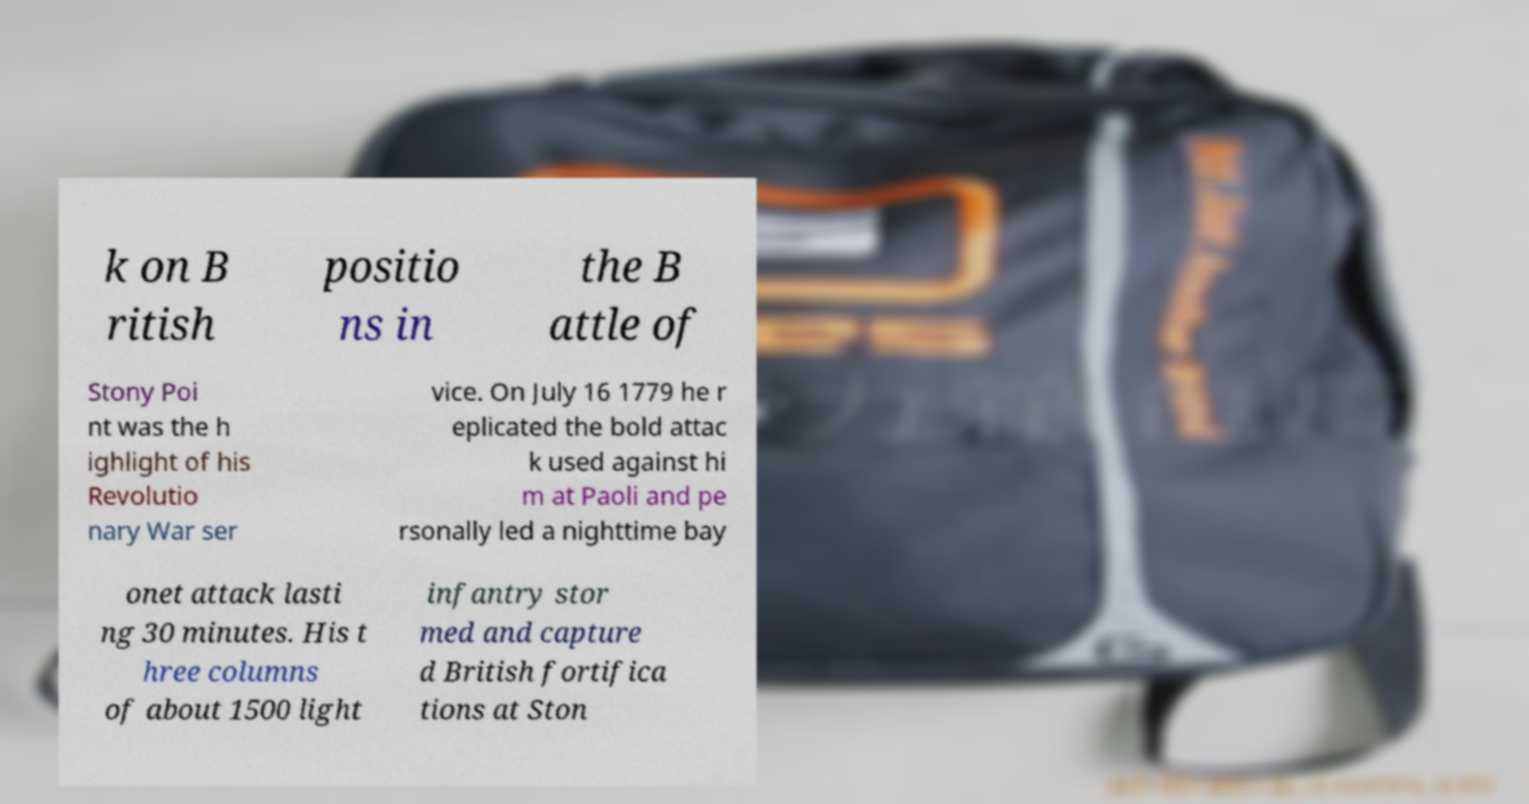Could you assist in decoding the text presented in this image and type it out clearly? k on B ritish positio ns in the B attle of Stony Poi nt was the h ighlight of his Revolutio nary War ser vice. On July 16 1779 he r eplicated the bold attac k used against hi m at Paoli and pe rsonally led a nighttime bay onet attack lasti ng 30 minutes. His t hree columns of about 1500 light infantry stor med and capture d British fortifica tions at Ston 